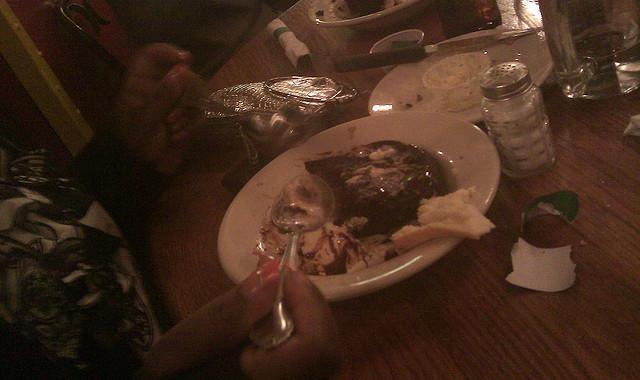How many people are there?
Give a very brief answer. 2. How many bowls are in the photo?
Give a very brief answer. 2. How many slices of pizza are there?
Give a very brief answer. 0. 